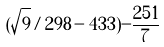<formula> <loc_0><loc_0><loc_500><loc_500>( \sqrt { 9 } / 2 9 8 - 4 3 3 ) - \frac { 2 5 1 } { 7 }</formula> 